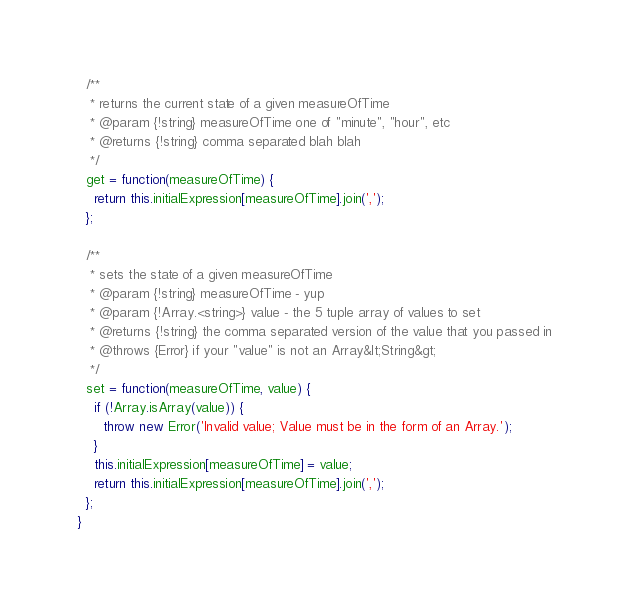Convert code to text. <code><loc_0><loc_0><loc_500><loc_500><_TypeScript_>  /**
   * returns the current state of a given measureOfTime
   * @param {!string} measureOfTime one of "minute", "hour", etc
   * @returns {!string} comma separated blah blah
   */
  get = function(measureOfTime) {
    return this.initialExpression[measureOfTime].join(',');
  };

  /**
   * sets the state of a given measureOfTime
   * @param {!string} measureOfTime - yup
   * @param {!Array.<string>} value - the 5 tuple array of values to set
   * @returns {!string} the comma separated version of the value that you passed in
   * @throws {Error} if your "value" is not an Array&lt;String&gt;
   */
  set = function(measureOfTime, value) {
    if (!Array.isArray(value)) {
      throw new Error('Invalid value; Value must be in the form of an Array.');
    }
    this.initialExpression[measureOfTime] = value;
    return this.initialExpression[measureOfTime].join(',');
  };
}
</code> 